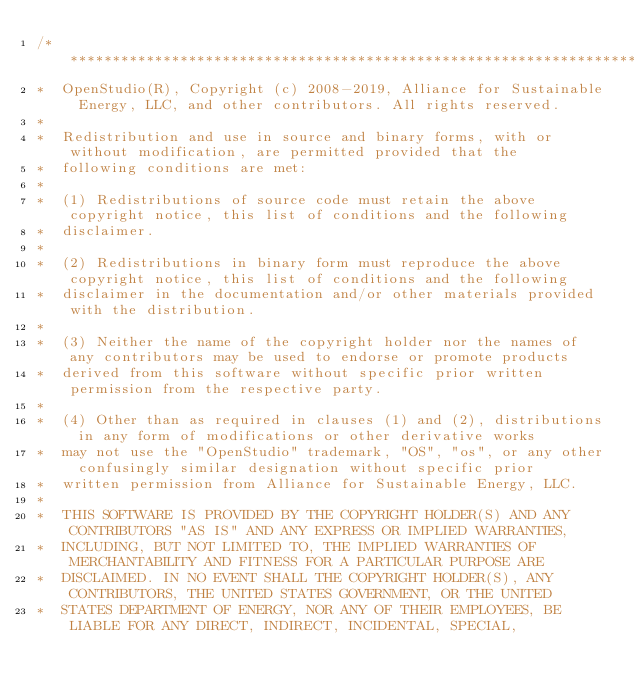Convert code to text. <code><loc_0><loc_0><loc_500><loc_500><_C++_>/***********************************************************************************************************************
*  OpenStudio(R), Copyright (c) 2008-2019, Alliance for Sustainable Energy, LLC, and other contributors. All rights reserved.
*
*  Redistribution and use in source and binary forms, with or without modification, are permitted provided that the
*  following conditions are met:
*
*  (1) Redistributions of source code must retain the above copyright notice, this list of conditions and the following
*  disclaimer.
*
*  (2) Redistributions in binary form must reproduce the above copyright notice, this list of conditions and the following
*  disclaimer in the documentation and/or other materials provided with the distribution.
*
*  (3) Neither the name of the copyright holder nor the names of any contributors may be used to endorse or promote products
*  derived from this software without specific prior written permission from the respective party.
*
*  (4) Other than as required in clauses (1) and (2), distributions in any form of modifications or other derivative works
*  may not use the "OpenStudio" trademark, "OS", "os", or any other confusingly similar designation without specific prior
*  written permission from Alliance for Sustainable Energy, LLC.
*
*  THIS SOFTWARE IS PROVIDED BY THE COPYRIGHT HOLDER(S) AND ANY CONTRIBUTORS "AS IS" AND ANY EXPRESS OR IMPLIED WARRANTIES,
*  INCLUDING, BUT NOT LIMITED TO, THE IMPLIED WARRANTIES OF MERCHANTABILITY AND FITNESS FOR A PARTICULAR PURPOSE ARE
*  DISCLAIMED. IN NO EVENT SHALL THE COPYRIGHT HOLDER(S), ANY CONTRIBUTORS, THE UNITED STATES GOVERNMENT, OR THE UNITED
*  STATES DEPARTMENT OF ENERGY, NOR ANY OF THEIR EMPLOYEES, BE LIABLE FOR ANY DIRECT, INDIRECT, INCIDENTAL, SPECIAL,</code> 